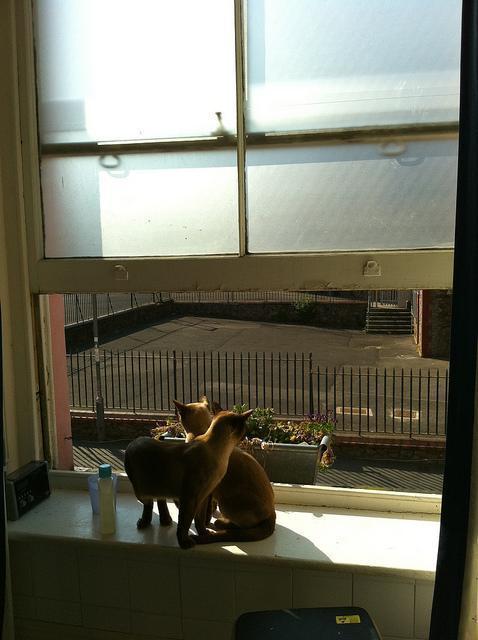How many cats are in the photo?
Give a very brief answer. 2. 